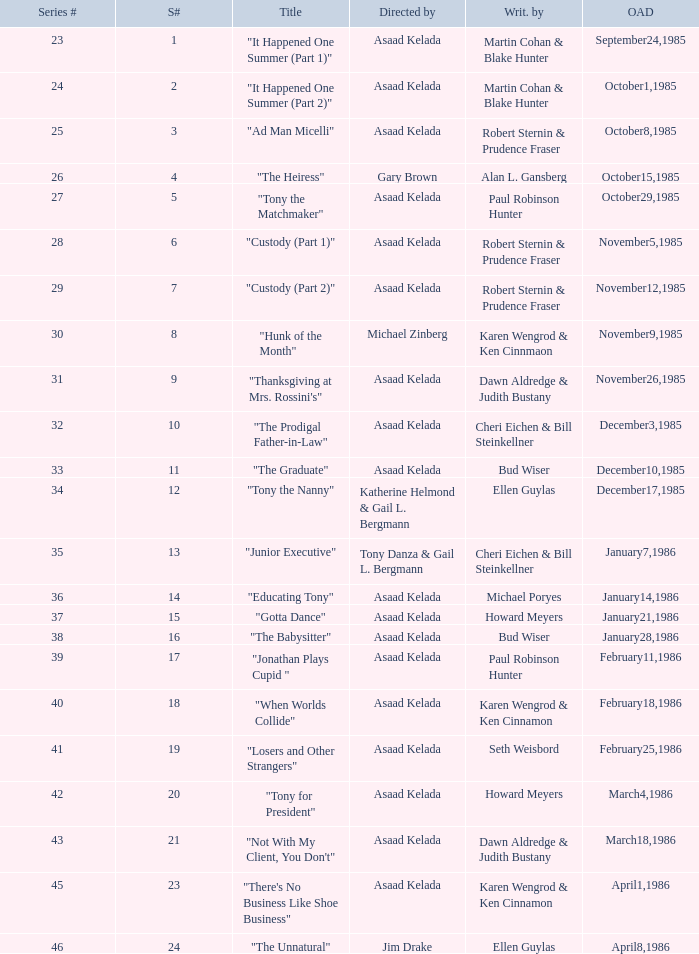Who were the authors of series episode #25? Robert Sternin & Prudence Fraser. 